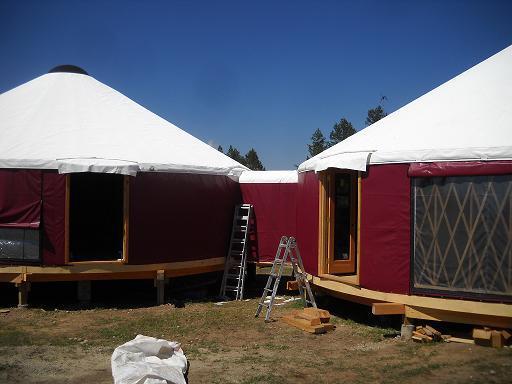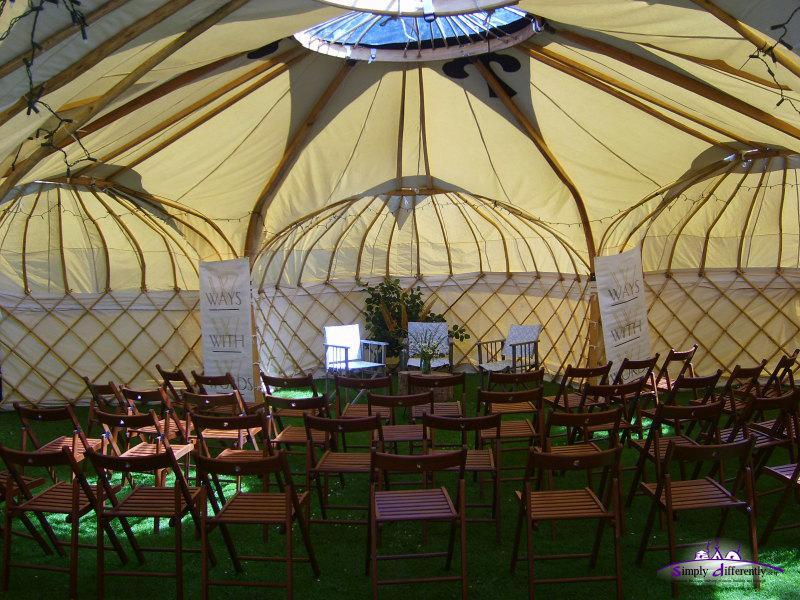The first image is the image on the left, the second image is the image on the right. For the images shown, is this caption "In one image, green round houses with light colored roofs are near tall pine trees." true? Answer yes or no. No. The first image is the image on the left, the second image is the image on the right. Examine the images to the left and right. Is the description "At least one image shows a walkway and railing leading to a yurt." accurate? Answer yes or no. No. 